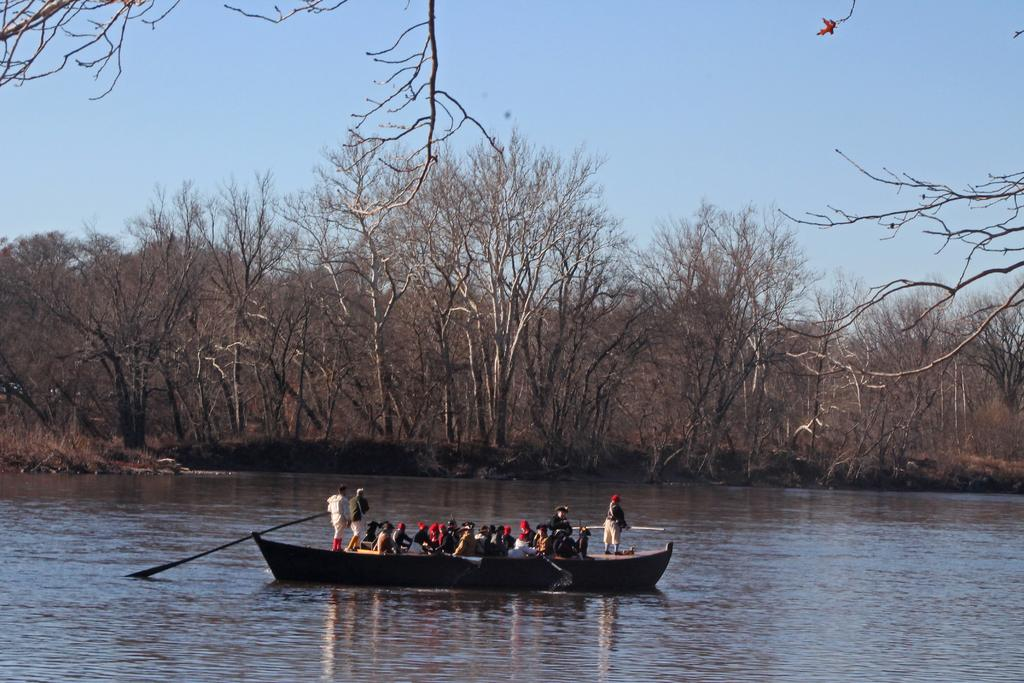Who or what is present in the image? There are people in the image. What are the people doing or where are they located? The people are on a boat. What is the boat situated on? The boat is on the water. What can be seen in the background of the image? There are trees and the sky visible in the background of the image. What type of soup is being served on the boat in the image? There is no soup present in the image; the people are on a boat, but no food or drink is mentioned or visible. 